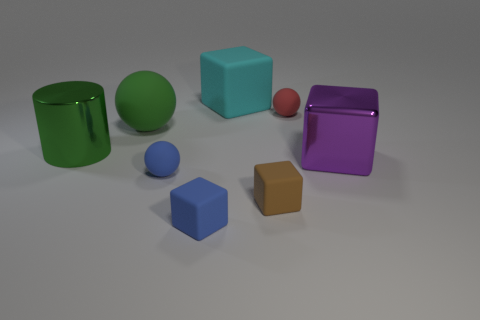Subtract 1 cubes. How many cubes are left? 3 Add 2 cyan things. How many objects exist? 10 Subtract all gray blocks. Subtract all brown balls. How many blocks are left? 4 Subtract all balls. How many objects are left? 5 Subtract 0 blue cylinders. How many objects are left? 8 Subtract all yellow cylinders. Subtract all tiny red things. How many objects are left? 7 Add 5 cyan rubber objects. How many cyan rubber objects are left? 6 Add 8 tiny red matte things. How many tiny red matte things exist? 9 